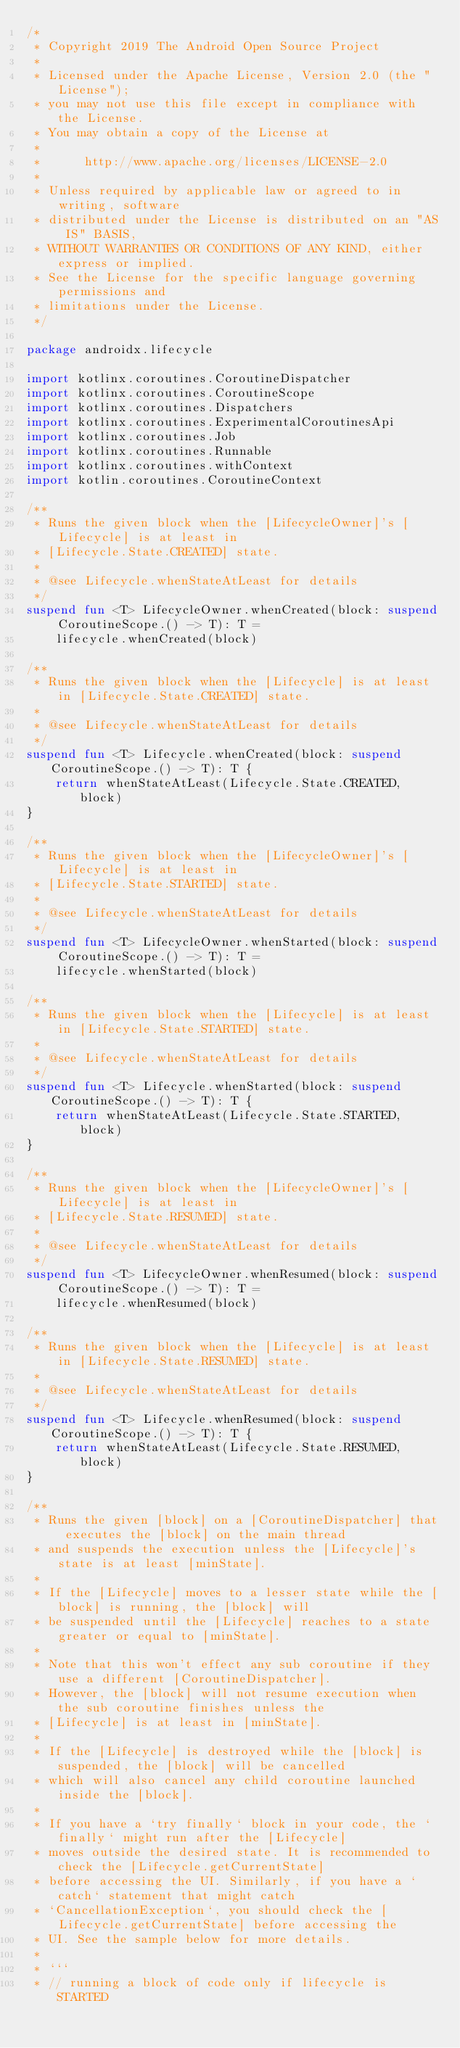<code> <loc_0><loc_0><loc_500><loc_500><_Kotlin_>/*
 * Copyright 2019 The Android Open Source Project
 *
 * Licensed under the Apache License, Version 2.0 (the "License");
 * you may not use this file except in compliance with the License.
 * You may obtain a copy of the License at
 *
 *      http://www.apache.org/licenses/LICENSE-2.0
 *
 * Unless required by applicable law or agreed to in writing, software
 * distributed under the License is distributed on an "AS IS" BASIS,
 * WITHOUT WARRANTIES OR CONDITIONS OF ANY KIND, either express or implied.
 * See the License for the specific language governing permissions and
 * limitations under the License.
 */

package androidx.lifecycle

import kotlinx.coroutines.CoroutineDispatcher
import kotlinx.coroutines.CoroutineScope
import kotlinx.coroutines.Dispatchers
import kotlinx.coroutines.ExperimentalCoroutinesApi
import kotlinx.coroutines.Job
import kotlinx.coroutines.Runnable
import kotlinx.coroutines.withContext
import kotlin.coroutines.CoroutineContext

/**
 * Runs the given block when the [LifecycleOwner]'s [Lifecycle] is at least in
 * [Lifecycle.State.CREATED] state.
 *
 * @see Lifecycle.whenStateAtLeast for details
 */
suspend fun <T> LifecycleOwner.whenCreated(block: suspend CoroutineScope.() -> T): T =
    lifecycle.whenCreated(block)

/**
 * Runs the given block when the [Lifecycle] is at least in [Lifecycle.State.CREATED] state.
 *
 * @see Lifecycle.whenStateAtLeast for details
 */
suspend fun <T> Lifecycle.whenCreated(block: suspend CoroutineScope.() -> T): T {
    return whenStateAtLeast(Lifecycle.State.CREATED, block)
}

/**
 * Runs the given block when the [LifecycleOwner]'s [Lifecycle] is at least in
 * [Lifecycle.State.STARTED] state.
 *
 * @see Lifecycle.whenStateAtLeast for details
 */
suspend fun <T> LifecycleOwner.whenStarted(block: suspend CoroutineScope.() -> T): T =
    lifecycle.whenStarted(block)

/**
 * Runs the given block when the [Lifecycle] is at least in [Lifecycle.State.STARTED] state.
 *
 * @see Lifecycle.whenStateAtLeast for details
 */
suspend fun <T> Lifecycle.whenStarted(block: suspend CoroutineScope.() -> T): T {
    return whenStateAtLeast(Lifecycle.State.STARTED, block)
}

/**
 * Runs the given block when the [LifecycleOwner]'s [Lifecycle] is at least in
 * [Lifecycle.State.RESUMED] state.
 *
 * @see Lifecycle.whenStateAtLeast for details
 */
suspend fun <T> LifecycleOwner.whenResumed(block: suspend CoroutineScope.() -> T): T =
    lifecycle.whenResumed(block)

/**
 * Runs the given block when the [Lifecycle] is at least in [Lifecycle.State.RESUMED] state.
 *
 * @see Lifecycle.whenStateAtLeast for details
 */
suspend fun <T> Lifecycle.whenResumed(block: suspend CoroutineScope.() -> T): T {
    return whenStateAtLeast(Lifecycle.State.RESUMED, block)
}

/**
 * Runs the given [block] on a [CoroutineDispatcher] that executes the [block] on the main thread
 * and suspends the execution unless the [Lifecycle]'s state is at least [minState].
 *
 * If the [Lifecycle] moves to a lesser state while the [block] is running, the [block] will
 * be suspended until the [Lifecycle] reaches to a state greater or equal to [minState].
 *
 * Note that this won't effect any sub coroutine if they use a different [CoroutineDispatcher].
 * However, the [block] will not resume execution when the sub coroutine finishes unless the
 * [Lifecycle] is at least in [minState].
 *
 * If the [Lifecycle] is destroyed while the [block] is suspended, the [block] will be cancelled
 * which will also cancel any child coroutine launched inside the [block].
 *
 * If you have a `try finally` block in your code, the `finally` might run after the [Lifecycle]
 * moves outside the desired state. It is recommended to check the [Lifecycle.getCurrentState]
 * before accessing the UI. Similarly, if you have a `catch` statement that might catch
 * `CancellationException`, you should check the [Lifecycle.getCurrentState] before accessing the
 * UI. See the sample below for more details.
 *
 * ```
 * // running a block of code only if lifecycle is STARTED</code> 